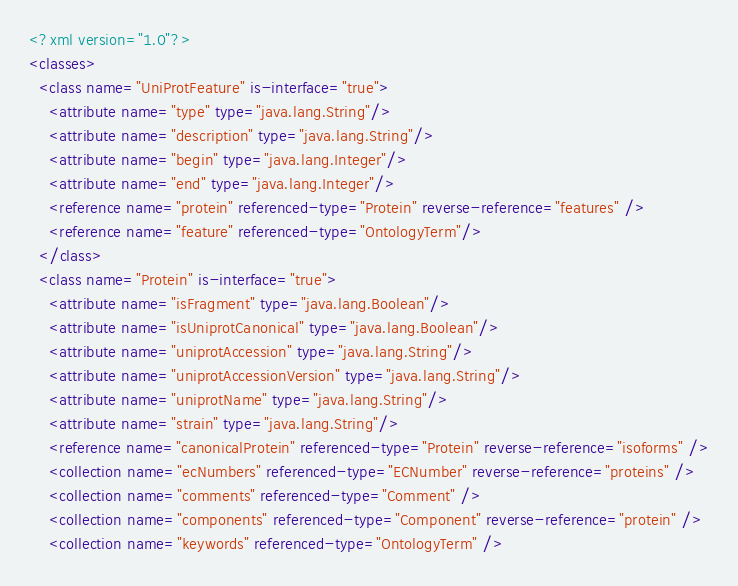<code> <loc_0><loc_0><loc_500><loc_500><_XML_><?xml version="1.0"?>
<classes>
  <class name="UniProtFeature" is-interface="true">
    <attribute name="type" type="java.lang.String"/>
    <attribute name="description" type="java.lang.String"/>
    <attribute name="begin" type="java.lang.Integer"/>
    <attribute name="end" type="java.lang.Integer"/>
    <reference name="protein" referenced-type="Protein" reverse-reference="features" />
    <reference name="feature" referenced-type="OntologyTerm"/>
  </class>
  <class name="Protein" is-interface="true">
    <attribute name="isFragment" type="java.lang.Boolean"/>
    <attribute name="isUniprotCanonical" type="java.lang.Boolean"/>
    <attribute name="uniprotAccession" type="java.lang.String"/>
    <attribute name="uniprotAccessionVersion" type="java.lang.String"/>
    <attribute name="uniprotName" type="java.lang.String"/>
    <attribute name="strain" type="java.lang.String"/>
    <reference name="canonicalProtein" referenced-type="Protein" reverse-reference="isoforms" />
    <collection name="ecNumbers" referenced-type="ECNumber" reverse-reference="proteins" />
    <collection name="comments" referenced-type="Comment" />
    <collection name="components" referenced-type="Component" reverse-reference="protein" />
    <collection name="keywords" referenced-type="OntologyTerm" /></code> 